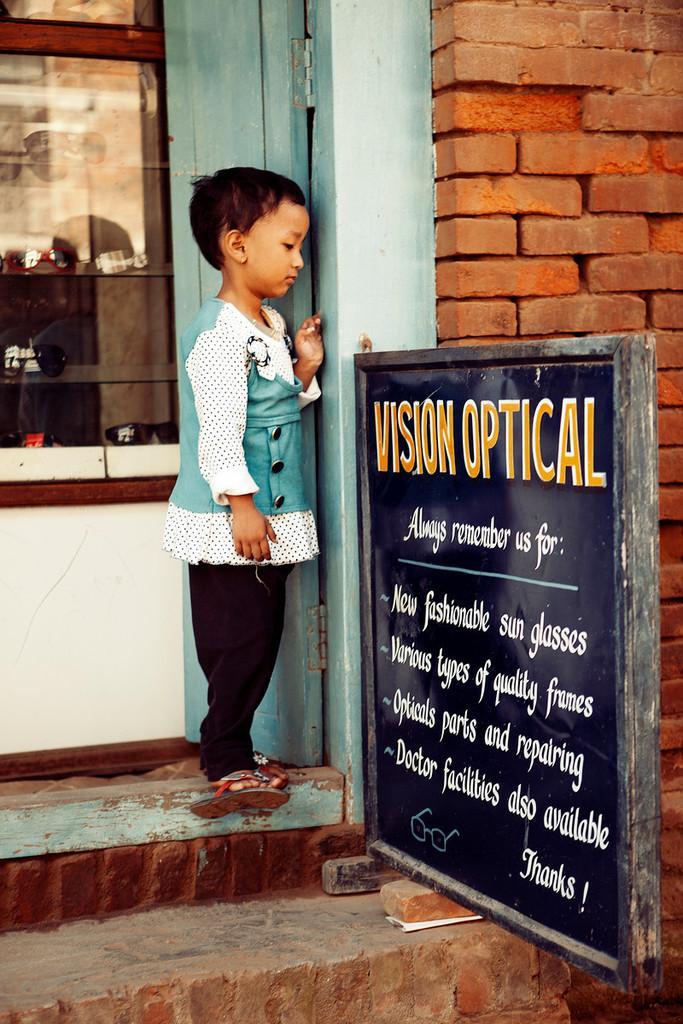Describe this image in one or two sentences. In this image I can see a girl is standing in the center. On the right side of this image I can see a black colour board and on it I can see something is written. I can also see the red colour wall on the right side. 